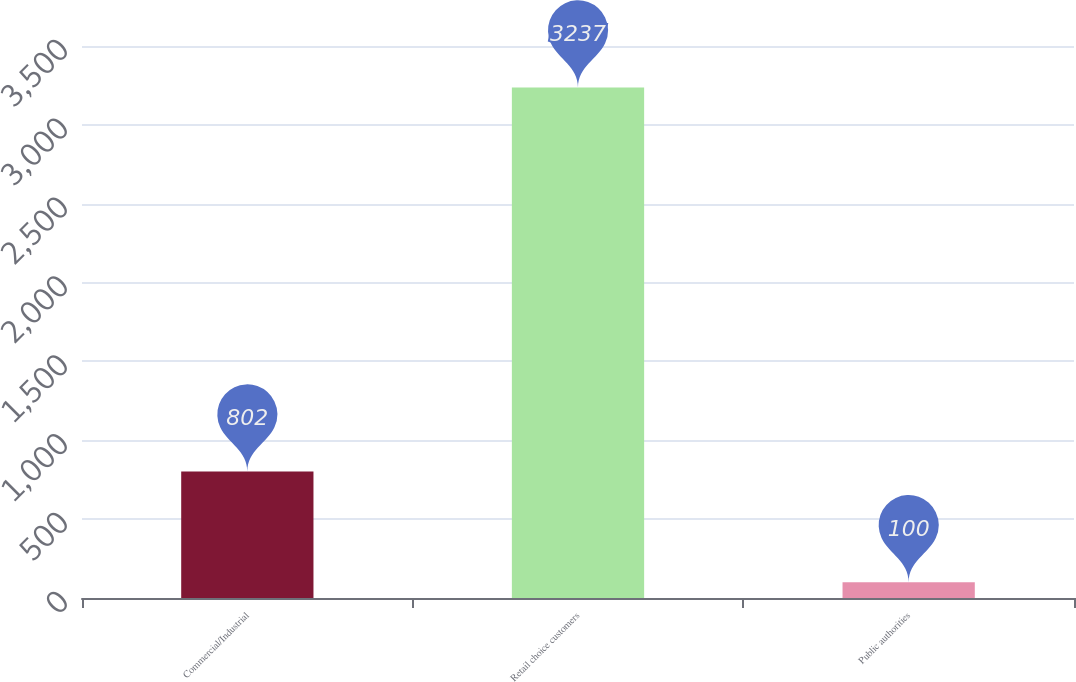Convert chart to OTSL. <chart><loc_0><loc_0><loc_500><loc_500><bar_chart><fcel>Commercial/Industrial<fcel>Retail choice customers<fcel>Public authorities<nl><fcel>802<fcel>3237<fcel>100<nl></chart> 